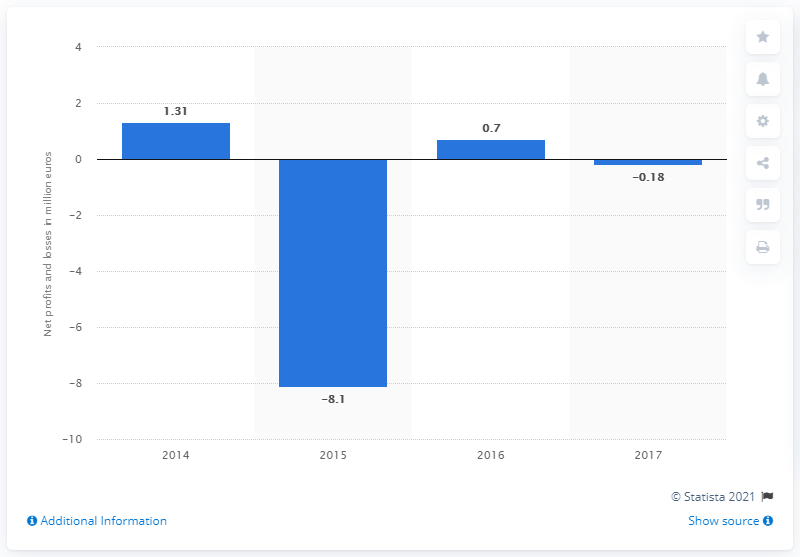List a handful of essential elements in this visual. In 2017, the net profit of Moschino S.p.A. was €0.7 million. 